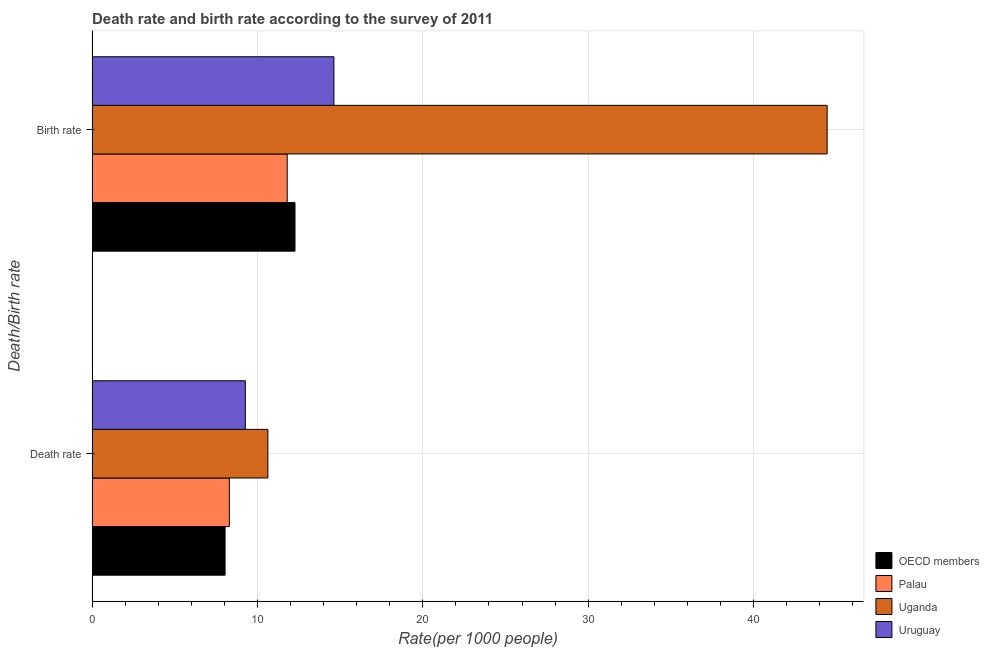How many different coloured bars are there?
Your answer should be very brief. 4. Are the number of bars per tick equal to the number of legend labels?
Give a very brief answer. Yes. Are the number of bars on each tick of the Y-axis equal?
Offer a terse response. Yes. How many bars are there on the 2nd tick from the bottom?
Provide a succinct answer. 4. What is the label of the 1st group of bars from the top?
Offer a very short reply. Birth rate. What is the birth rate in Uruguay?
Offer a terse response. 14.62. Across all countries, what is the maximum birth rate?
Provide a succinct answer. 44.45. Across all countries, what is the minimum death rate?
Keep it short and to the point. 8.04. In which country was the death rate maximum?
Ensure brevity in your answer.  Uganda. In which country was the death rate minimum?
Keep it short and to the point. OECD members. What is the total birth rate in the graph?
Provide a succinct answer. 83.15. What is the difference between the birth rate in OECD members and that in Palau?
Offer a very short reply. 0.47. What is the difference between the birth rate in OECD members and the death rate in Palau?
Provide a short and direct response. 3.97. What is the average death rate per country?
Your response must be concise. 9.06. What is the difference between the death rate and birth rate in Palau?
Keep it short and to the point. -3.5. What is the ratio of the birth rate in OECD members to that in Palau?
Offer a very short reply. 1.04. In how many countries, is the birth rate greater than the average birth rate taken over all countries?
Your response must be concise. 1. What does the 1st bar from the top in Birth rate represents?
Give a very brief answer. Uruguay. How many bars are there?
Give a very brief answer. 8. How many countries are there in the graph?
Your answer should be very brief. 4. What is the difference between two consecutive major ticks on the X-axis?
Offer a terse response. 10. Does the graph contain grids?
Keep it short and to the point. Yes. How are the legend labels stacked?
Ensure brevity in your answer.  Vertical. What is the title of the graph?
Ensure brevity in your answer.  Death rate and birth rate according to the survey of 2011. What is the label or title of the X-axis?
Ensure brevity in your answer.  Rate(per 1000 people). What is the label or title of the Y-axis?
Your response must be concise. Death/Birth rate. What is the Rate(per 1000 people) in OECD members in Death rate?
Provide a short and direct response. 8.04. What is the Rate(per 1000 people) of Palau in Death rate?
Provide a succinct answer. 8.3. What is the Rate(per 1000 people) of Uganda in Death rate?
Provide a succinct answer. 10.63. What is the Rate(per 1000 people) in Uruguay in Death rate?
Offer a very short reply. 9.27. What is the Rate(per 1000 people) in OECD members in Birth rate?
Offer a terse response. 12.27. What is the Rate(per 1000 people) of Uganda in Birth rate?
Offer a terse response. 44.45. What is the Rate(per 1000 people) in Uruguay in Birth rate?
Provide a succinct answer. 14.62. Across all Death/Birth rate, what is the maximum Rate(per 1000 people) in OECD members?
Ensure brevity in your answer.  12.27. Across all Death/Birth rate, what is the maximum Rate(per 1000 people) in Uganda?
Offer a very short reply. 44.45. Across all Death/Birth rate, what is the maximum Rate(per 1000 people) in Uruguay?
Offer a very short reply. 14.62. Across all Death/Birth rate, what is the minimum Rate(per 1000 people) of OECD members?
Your answer should be very brief. 8.04. Across all Death/Birth rate, what is the minimum Rate(per 1000 people) in Palau?
Your response must be concise. 8.3. Across all Death/Birth rate, what is the minimum Rate(per 1000 people) of Uganda?
Provide a succinct answer. 10.63. Across all Death/Birth rate, what is the minimum Rate(per 1000 people) of Uruguay?
Your answer should be compact. 9.27. What is the total Rate(per 1000 people) in OECD members in the graph?
Your response must be concise. 20.31. What is the total Rate(per 1000 people) of Palau in the graph?
Keep it short and to the point. 20.1. What is the total Rate(per 1000 people) of Uganda in the graph?
Your answer should be compact. 55.08. What is the total Rate(per 1000 people) in Uruguay in the graph?
Ensure brevity in your answer.  23.89. What is the difference between the Rate(per 1000 people) in OECD members in Death rate and that in Birth rate?
Your response must be concise. -4.23. What is the difference between the Rate(per 1000 people) in Palau in Death rate and that in Birth rate?
Offer a terse response. -3.5. What is the difference between the Rate(per 1000 people) of Uganda in Death rate and that in Birth rate?
Your answer should be compact. -33.82. What is the difference between the Rate(per 1000 people) of Uruguay in Death rate and that in Birth rate?
Keep it short and to the point. -5.36. What is the difference between the Rate(per 1000 people) of OECD members in Death rate and the Rate(per 1000 people) of Palau in Birth rate?
Offer a very short reply. -3.76. What is the difference between the Rate(per 1000 people) of OECD members in Death rate and the Rate(per 1000 people) of Uganda in Birth rate?
Give a very brief answer. -36.41. What is the difference between the Rate(per 1000 people) in OECD members in Death rate and the Rate(per 1000 people) in Uruguay in Birth rate?
Make the answer very short. -6.58. What is the difference between the Rate(per 1000 people) of Palau in Death rate and the Rate(per 1000 people) of Uganda in Birth rate?
Ensure brevity in your answer.  -36.15. What is the difference between the Rate(per 1000 people) in Palau in Death rate and the Rate(per 1000 people) in Uruguay in Birth rate?
Your answer should be compact. -6.32. What is the difference between the Rate(per 1000 people) of Uganda in Death rate and the Rate(per 1000 people) of Uruguay in Birth rate?
Provide a succinct answer. -3.99. What is the average Rate(per 1000 people) of OECD members per Death/Birth rate?
Give a very brief answer. 10.16. What is the average Rate(per 1000 people) in Palau per Death/Birth rate?
Offer a terse response. 10.05. What is the average Rate(per 1000 people) in Uganda per Death/Birth rate?
Provide a short and direct response. 27.54. What is the average Rate(per 1000 people) of Uruguay per Death/Birth rate?
Give a very brief answer. 11.95. What is the difference between the Rate(per 1000 people) in OECD members and Rate(per 1000 people) in Palau in Death rate?
Your response must be concise. -0.26. What is the difference between the Rate(per 1000 people) in OECD members and Rate(per 1000 people) in Uganda in Death rate?
Offer a terse response. -2.59. What is the difference between the Rate(per 1000 people) of OECD members and Rate(per 1000 people) of Uruguay in Death rate?
Keep it short and to the point. -1.22. What is the difference between the Rate(per 1000 people) in Palau and Rate(per 1000 people) in Uganda in Death rate?
Keep it short and to the point. -2.33. What is the difference between the Rate(per 1000 people) of Palau and Rate(per 1000 people) of Uruguay in Death rate?
Ensure brevity in your answer.  -0.97. What is the difference between the Rate(per 1000 people) in Uganda and Rate(per 1000 people) in Uruguay in Death rate?
Give a very brief answer. 1.36. What is the difference between the Rate(per 1000 people) of OECD members and Rate(per 1000 people) of Palau in Birth rate?
Your answer should be compact. 0.47. What is the difference between the Rate(per 1000 people) of OECD members and Rate(per 1000 people) of Uganda in Birth rate?
Your answer should be compact. -32.18. What is the difference between the Rate(per 1000 people) of OECD members and Rate(per 1000 people) of Uruguay in Birth rate?
Your response must be concise. -2.35. What is the difference between the Rate(per 1000 people) of Palau and Rate(per 1000 people) of Uganda in Birth rate?
Keep it short and to the point. -32.65. What is the difference between the Rate(per 1000 people) in Palau and Rate(per 1000 people) in Uruguay in Birth rate?
Your answer should be very brief. -2.82. What is the difference between the Rate(per 1000 people) in Uganda and Rate(per 1000 people) in Uruguay in Birth rate?
Ensure brevity in your answer.  29.83. What is the ratio of the Rate(per 1000 people) in OECD members in Death rate to that in Birth rate?
Your answer should be compact. 0.66. What is the ratio of the Rate(per 1000 people) of Palau in Death rate to that in Birth rate?
Provide a short and direct response. 0.7. What is the ratio of the Rate(per 1000 people) in Uganda in Death rate to that in Birth rate?
Keep it short and to the point. 0.24. What is the ratio of the Rate(per 1000 people) of Uruguay in Death rate to that in Birth rate?
Your response must be concise. 0.63. What is the difference between the highest and the second highest Rate(per 1000 people) in OECD members?
Give a very brief answer. 4.23. What is the difference between the highest and the second highest Rate(per 1000 people) in Palau?
Provide a short and direct response. 3.5. What is the difference between the highest and the second highest Rate(per 1000 people) in Uganda?
Offer a very short reply. 33.82. What is the difference between the highest and the second highest Rate(per 1000 people) in Uruguay?
Keep it short and to the point. 5.36. What is the difference between the highest and the lowest Rate(per 1000 people) in OECD members?
Keep it short and to the point. 4.23. What is the difference between the highest and the lowest Rate(per 1000 people) of Uganda?
Ensure brevity in your answer.  33.82. What is the difference between the highest and the lowest Rate(per 1000 people) of Uruguay?
Your response must be concise. 5.36. 